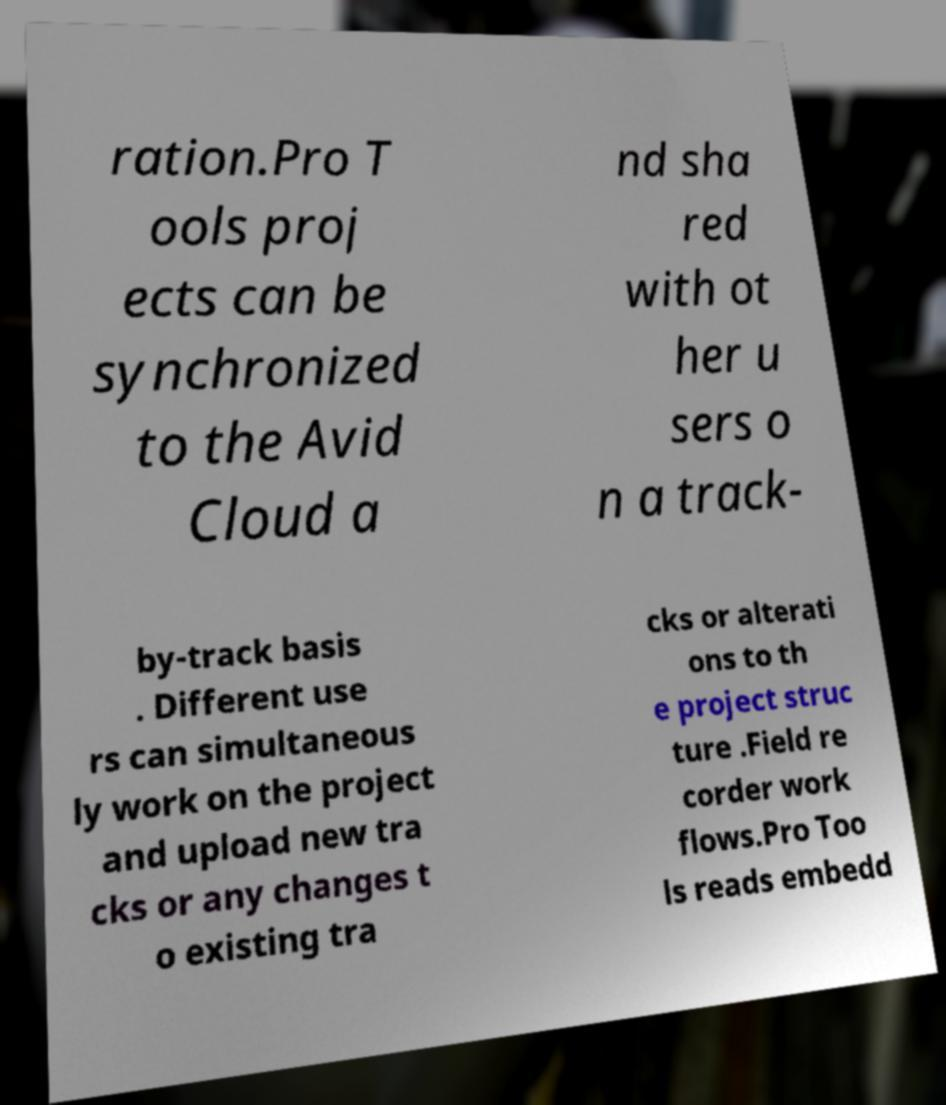Can you read and provide the text displayed in the image?This photo seems to have some interesting text. Can you extract and type it out for me? ration.Pro T ools proj ects can be synchronized to the Avid Cloud a nd sha red with ot her u sers o n a track- by-track basis . Different use rs can simultaneous ly work on the project and upload new tra cks or any changes t o existing tra cks or alterati ons to th e project struc ture .Field re corder work flows.Pro Too ls reads embedd 